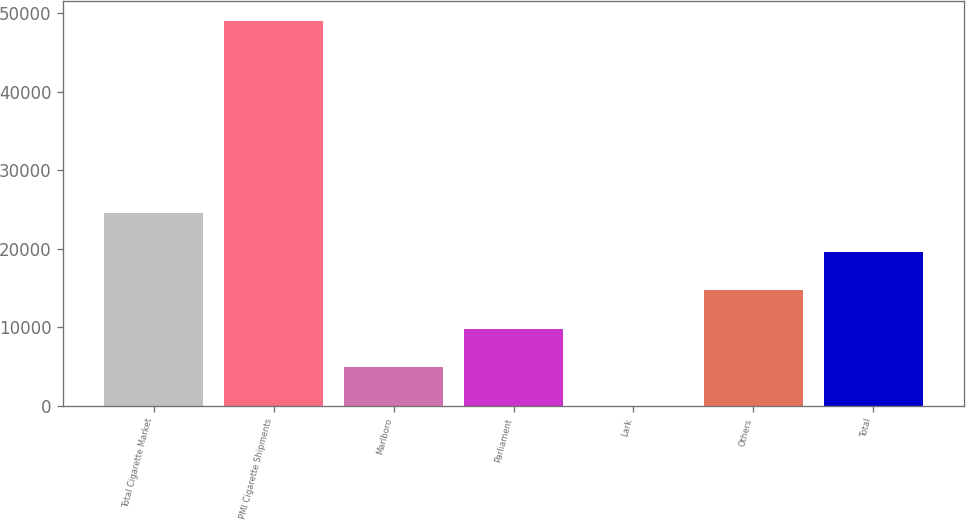<chart> <loc_0><loc_0><loc_500><loc_500><bar_chart><fcel>Total Cigarette Market<fcel>PMI Cigarette Shipments<fcel>Marlboro<fcel>Parliament<fcel>Lark<fcel>Others<fcel>Total<nl><fcel>24510.8<fcel>49014<fcel>4908.24<fcel>9808.88<fcel>7.6<fcel>14709.5<fcel>19610.2<nl></chart> 